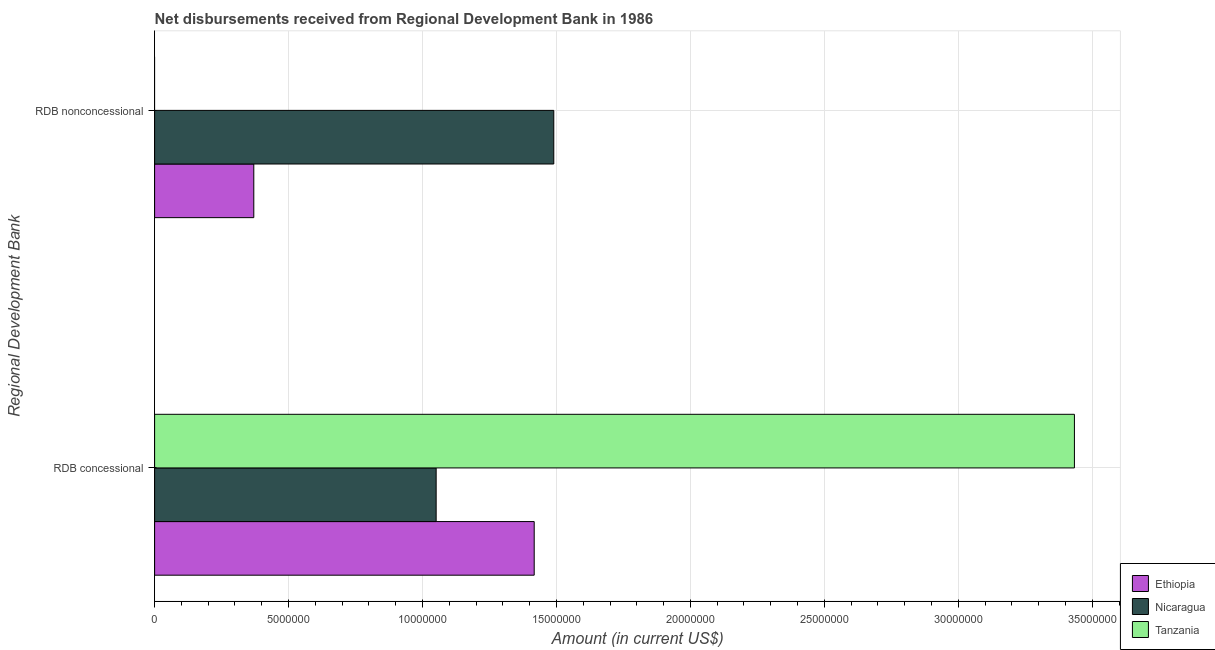How many different coloured bars are there?
Ensure brevity in your answer.  3. How many groups of bars are there?
Make the answer very short. 2. Are the number of bars per tick equal to the number of legend labels?
Give a very brief answer. No. Are the number of bars on each tick of the Y-axis equal?
Your answer should be compact. No. What is the label of the 1st group of bars from the top?
Your answer should be compact. RDB nonconcessional. What is the net non concessional disbursements from rdb in Ethiopia?
Offer a terse response. 3.70e+06. Across all countries, what is the maximum net concessional disbursements from rdb?
Offer a terse response. 3.43e+07. Across all countries, what is the minimum net non concessional disbursements from rdb?
Give a very brief answer. 0. In which country was the net concessional disbursements from rdb maximum?
Provide a short and direct response. Tanzania. What is the total net concessional disbursements from rdb in the graph?
Your answer should be very brief. 5.90e+07. What is the difference between the net non concessional disbursements from rdb in Nicaragua and that in Ethiopia?
Keep it short and to the point. 1.12e+07. What is the difference between the net non concessional disbursements from rdb in Ethiopia and the net concessional disbursements from rdb in Nicaragua?
Give a very brief answer. -6.81e+06. What is the average net non concessional disbursements from rdb per country?
Keep it short and to the point. 6.20e+06. What is the difference between the net non concessional disbursements from rdb and net concessional disbursements from rdb in Nicaragua?
Your answer should be compact. 4.39e+06. In how many countries, is the net non concessional disbursements from rdb greater than 2000000 US$?
Keep it short and to the point. 2. What is the ratio of the net concessional disbursements from rdb in Tanzania to that in Nicaragua?
Give a very brief answer. 3.27. Is the net non concessional disbursements from rdb in Nicaragua less than that in Ethiopia?
Keep it short and to the point. No. How many bars are there?
Your answer should be very brief. 5. Are all the bars in the graph horizontal?
Your answer should be very brief. Yes. How many countries are there in the graph?
Provide a succinct answer. 3. Are the values on the major ticks of X-axis written in scientific E-notation?
Give a very brief answer. No. Where does the legend appear in the graph?
Offer a terse response. Bottom right. How many legend labels are there?
Ensure brevity in your answer.  3. What is the title of the graph?
Offer a very short reply. Net disbursements received from Regional Development Bank in 1986. What is the label or title of the X-axis?
Offer a very short reply. Amount (in current US$). What is the label or title of the Y-axis?
Keep it short and to the point. Regional Development Bank. What is the Amount (in current US$) in Ethiopia in RDB concessional?
Give a very brief answer. 1.42e+07. What is the Amount (in current US$) in Nicaragua in RDB concessional?
Give a very brief answer. 1.05e+07. What is the Amount (in current US$) of Tanzania in RDB concessional?
Provide a succinct answer. 3.43e+07. What is the Amount (in current US$) of Ethiopia in RDB nonconcessional?
Your answer should be very brief. 3.70e+06. What is the Amount (in current US$) of Nicaragua in RDB nonconcessional?
Your answer should be compact. 1.49e+07. What is the Amount (in current US$) of Tanzania in RDB nonconcessional?
Give a very brief answer. 0. Across all Regional Development Bank, what is the maximum Amount (in current US$) in Ethiopia?
Provide a succinct answer. 1.42e+07. Across all Regional Development Bank, what is the maximum Amount (in current US$) in Nicaragua?
Your response must be concise. 1.49e+07. Across all Regional Development Bank, what is the maximum Amount (in current US$) in Tanzania?
Ensure brevity in your answer.  3.43e+07. Across all Regional Development Bank, what is the minimum Amount (in current US$) in Ethiopia?
Your response must be concise. 3.70e+06. Across all Regional Development Bank, what is the minimum Amount (in current US$) in Nicaragua?
Your answer should be very brief. 1.05e+07. Across all Regional Development Bank, what is the minimum Amount (in current US$) in Tanzania?
Provide a succinct answer. 0. What is the total Amount (in current US$) in Ethiopia in the graph?
Make the answer very short. 1.79e+07. What is the total Amount (in current US$) of Nicaragua in the graph?
Keep it short and to the point. 2.54e+07. What is the total Amount (in current US$) in Tanzania in the graph?
Your answer should be compact. 3.43e+07. What is the difference between the Amount (in current US$) of Ethiopia in RDB concessional and that in RDB nonconcessional?
Offer a terse response. 1.05e+07. What is the difference between the Amount (in current US$) of Nicaragua in RDB concessional and that in RDB nonconcessional?
Make the answer very short. -4.39e+06. What is the difference between the Amount (in current US$) in Ethiopia in RDB concessional and the Amount (in current US$) in Nicaragua in RDB nonconcessional?
Provide a succinct answer. -7.31e+05. What is the average Amount (in current US$) in Ethiopia per Regional Development Bank?
Ensure brevity in your answer.  8.94e+06. What is the average Amount (in current US$) in Nicaragua per Regional Development Bank?
Offer a terse response. 1.27e+07. What is the average Amount (in current US$) of Tanzania per Regional Development Bank?
Give a very brief answer. 1.72e+07. What is the difference between the Amount (in current US$) of Ethiopia and Amount (in current US$) of Nicaragua in RDB concessional?
Give a very brief answer. 3.66e+06. What is the difference between the Amount (in current US$) in Ethiopia and Amount (in current US$) in Tanzania in RDB concessional?
Give a very brief answer. -2.02e+07. What is the difference between the Amount (in current US$) in Nicaragua and Amount (in current US$) in Tanzania in RDB concessional?
Your response must be concise. -2.38e+07. What is the difference between the Amount (in current US$) of Ethiopia and Amount (in current US$) of Nicaragua in RDB nonconcessional?
Your response must be concise. -1.12e+07. What is the ratio of the Amount (in current US$) in Ethiopia in RDB concessional to that in RDB nonconcessional?
Provide a short and direct response. 3.83. What is the ratio of the Amount (in current US$) of Nicaragua in RDB concessional to that in RDB nonconcessional?
Keep it short and to the point. 0.71. What is the difference between the highest and the second highest Amount (in current US$) of Ethiopia?
Ensure brevity in your answer.  1.05e+07. What is the difference between the highest and the second highest Amount (in current US$) of Nicaragua?
Offer a very short reply. 4.39e+06. What is the difference between the highest and the lowest Amount (in current US$) in Ethiopia?
Your answer should be very brief. 1.05e+07. What is the difference between the highest and the lowest Amount (in current US$) in Nicaragua?
Keep it short and to the point. 4.39e+06. What is the difference between the highest and the lowest Amount (in current US$) of Tanzania?
Provide a short and direct response. 3.43e+07. 